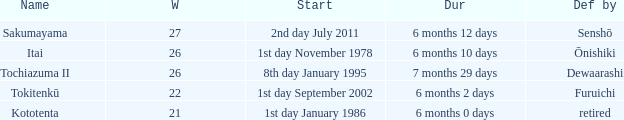Which duration was defeated by retired? 6 months 0 days. 